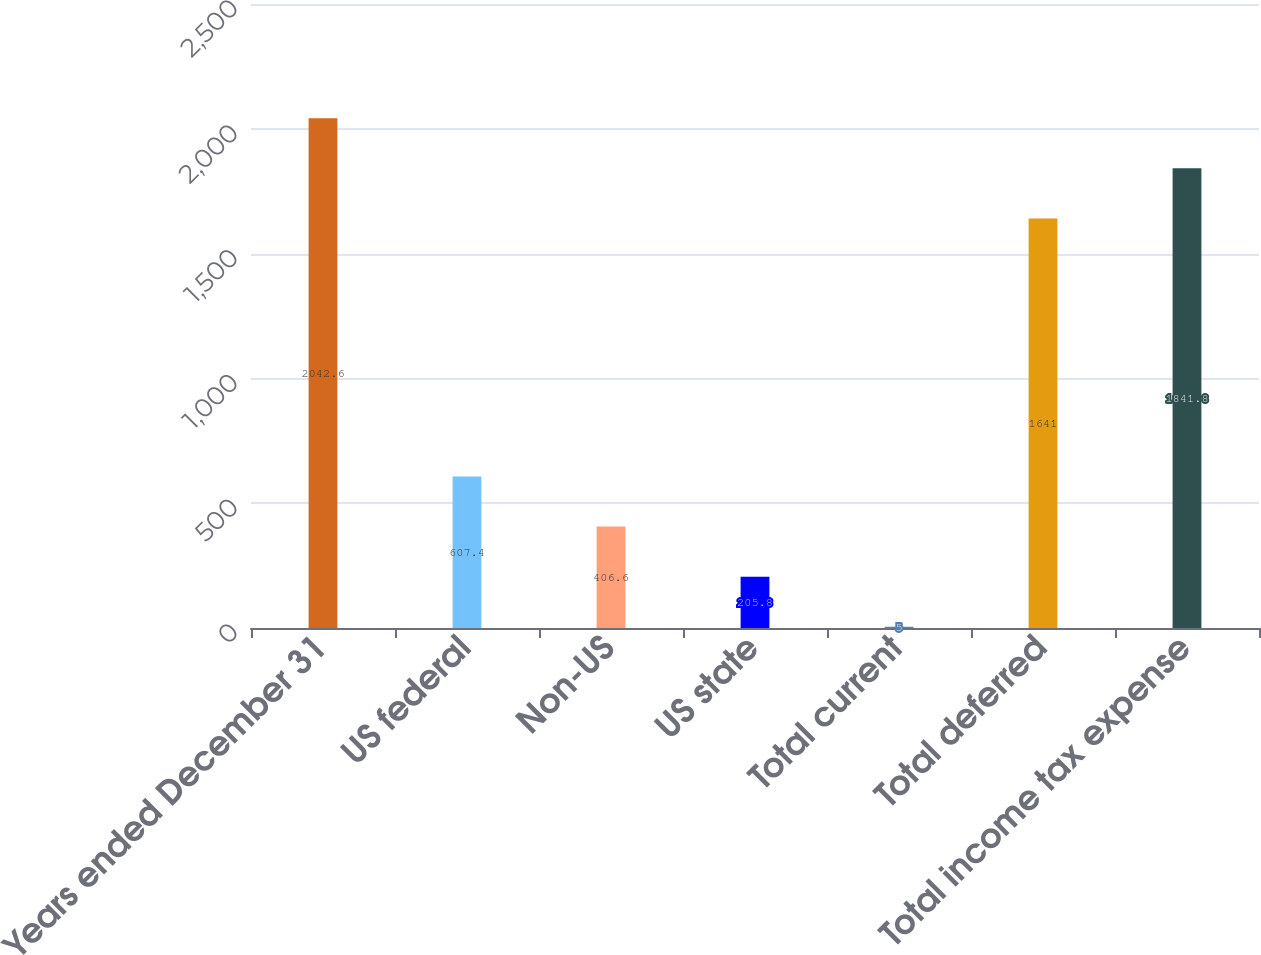Convert chart. <chart><loc_0><loc_0><loc_500><loc_500><bar_chart><fcel>Years ended December 31<fcel>US federal<fcel>Non-US<fcel>US state<fcel>Total current<fcel>Total deferred<fcel>Total income tax expense<nl><fcel>2042.6<fcel>607.4<fcel>406.6<fcel>205.8<fcel>5<fcel>1641<fcel>1841.8<nl></chart> 